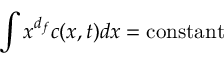<formula> <loc_0><loc_0><loc_500><loc_500>\int x ^ { d _ { f } } c ( x , t ) d x = { c o n s t a n t }</formula> 